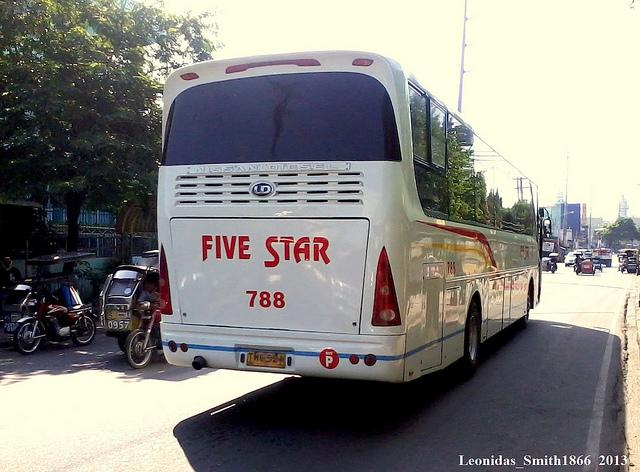What letter is on the bumper? Please explain your reasoning. p. The letter "p" is shown on the sticker. 